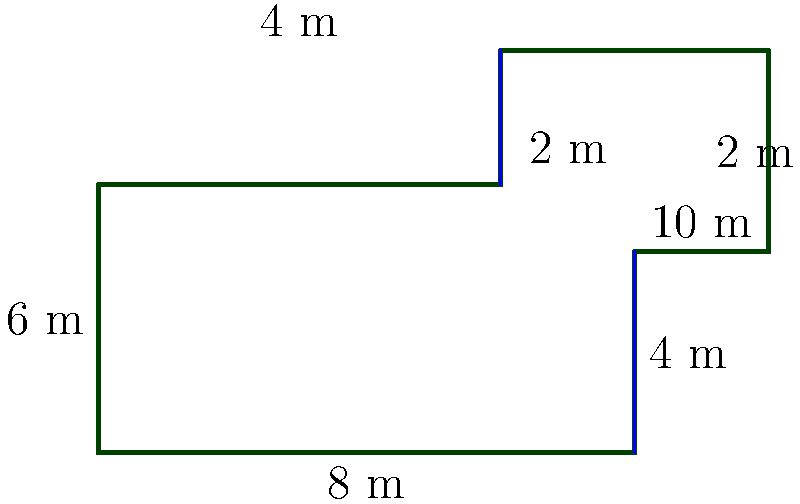As the language school director, you're planning to install baseboards along the walls of a newly designed irregularly shaped classroom. Calculate the perimeter of the classroom floor plan to determine the total length of baseboards needed. All measurements are given in meters. To calculate the perimeter of the irregularly shaped classroom, we need to sum up the lengths of all sides:

1. Bottom side: $8$ m
2. Right side (lower part): $3$ m
3. Small extension on the right: $2$ m
4. Upper right side: $3$ m
5. Top side: $4$ m
6. Small indentation on the left: $2$ m
7. Left side (upper part): $2$ m
8. Left side (lower part): $4$ m

Now, let's add all these lengths:

$$\text{Perimeter} = 8 + 3 + 2 + 3 + 4 + 2 + 2 + 4 = 28$$

Therefore, the total perimeter of the classroom is $28$ meters.
Answer: $28$ m 